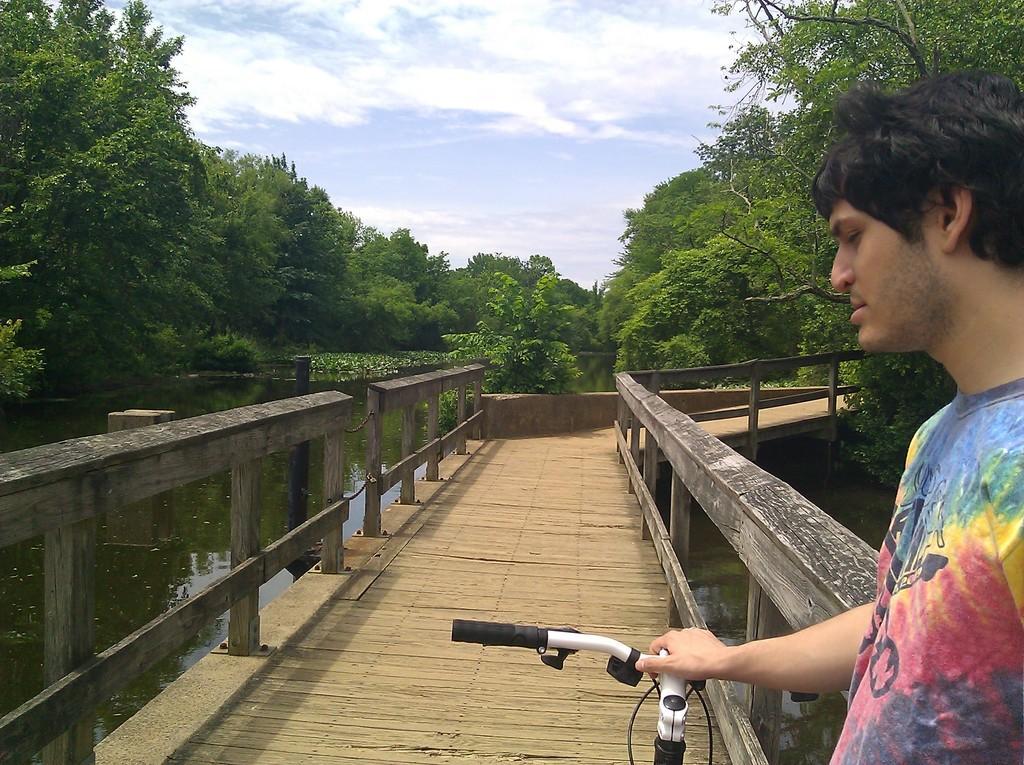In one or two sentences, can you explain what this image depicts? In this image there is a man standing on the bridge by holding the handle of the cycle. There are trees all around the bridge. Behind the bridge there is water. At the top there is sky. 